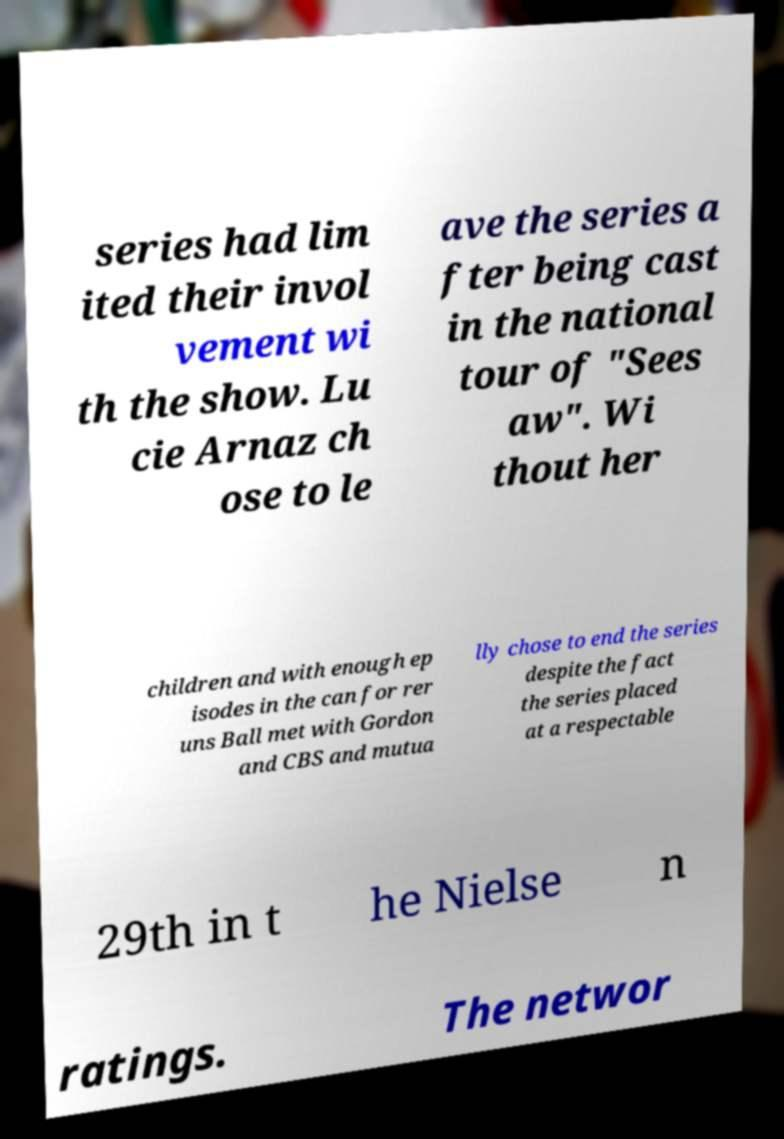I need the written content from this picture converted into text. Can you do that? series had lim ited their invol vement wi th the show. Lu cie Arnaz ch ose to le ave the series a fter being cast in the national tour of "Sees aw". Wi thout her children and with enough ep isodes in the can for rer uns Ball met with Gordon and CBS and mutua lly chose to end the series despite the fact the series placed at a respectable 29th in t he Nielse n ratings. The networ 